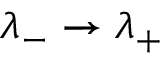Convert formula to latex. <formula><loc_0><loc_0><loc_500><loc_500>\lambda _ { - } \to \lambda _ { + }</formula> 